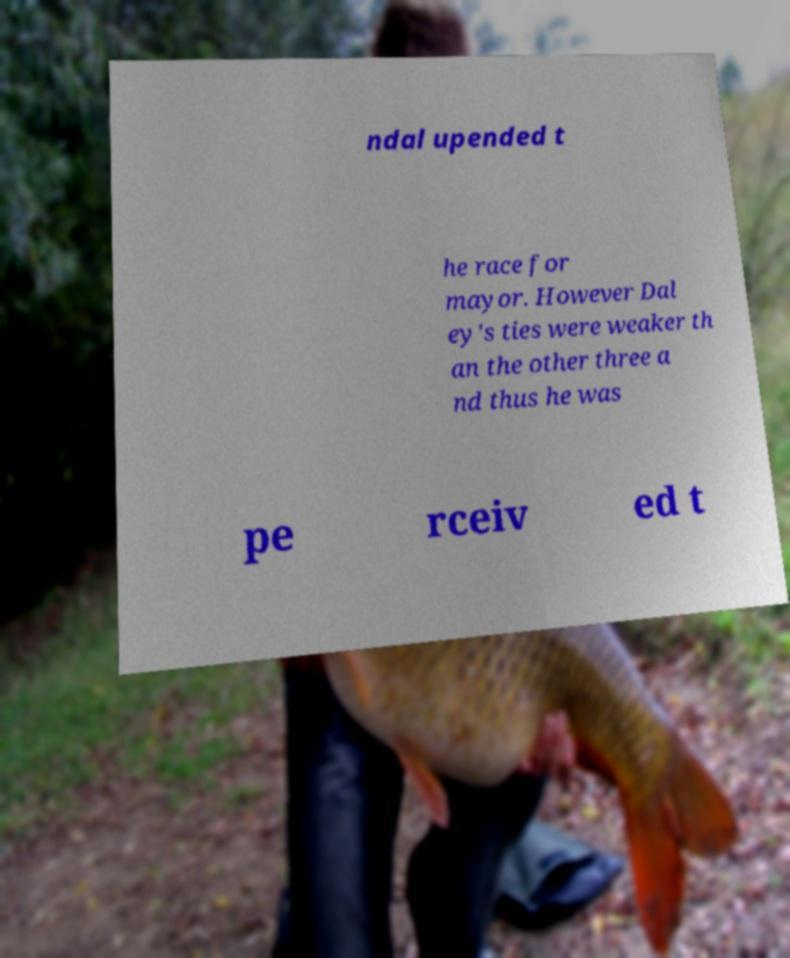Please read and relay the text visible in this image. What does it say? ndal upended t he race for mayor. However Dal ey's ties were weaker th an the other three a nd thus he was pe rceiv ed t 